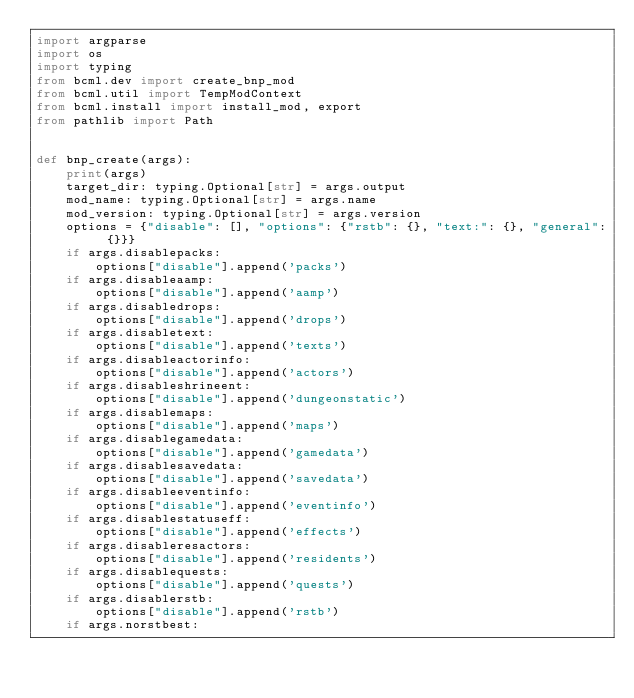<code> <loc_0><loc_0><loc_500><loc_500><_Python_>import argparse
import os
import typing
from bcml.dev import create_bnp_mod
from bcml.util import TempModContext
from bcml.install import install_mod, export
from pathlib import Path


def bnp_create(args):
    print(args)
    target_dir: typing.Optional[str] = args.output
    mod_name: typing.Optional[str] = args.name
    mod_version: typing.Optional[str] = args.version
    options = {"disable": [], "options": {"rstb": {}, "text:": {}, "general": {}}}
    if args.disablepacks:
        options["disable"].append('packs')
    if args.disableaamp:
        options["disable"].append('aamp')
    if args.disabledrops:
        options["disable"].append('drops')
    if args.disabletext:
        options["disable"].append('texts')
    if args.disableactorinfo:
        options["disable"].append('actors')
    if args.disableshrineent:
        options["disable"].append('dungeonstatic')
    if args.disablemaps:
        options["disable"].append('maps')
    if args.disablegamedata:
        options["disable"].append('gamedata')
    if args.disablesavedata:
        options["disable"].append('savedata')
    if args.disableeventinfo:
        options["disable"].append('eventinfo')
    if args.disablestatuseff:
        options["disable"].append('effects')
    if args.disableresactors:
        options["disable"].append('residents')
    if args.disablequests:
        options["disable"].append('quests')
    if args.disablerstb:
        options["disable"].append('rstb')
    if args.norstbest:</code> 